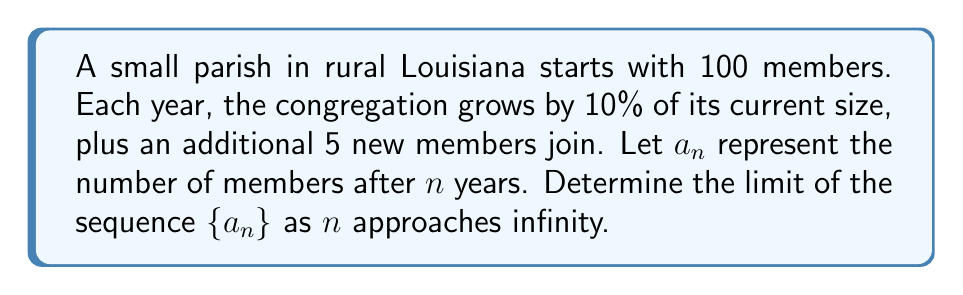Solve this math problem. Let's approach this step-by-step:

1) First, we need to find the recursive formula for $a_n$:
   $a_{n+1} = 1.1a_n + 5$, with $a_0 = 100$

2) To find the limit, we assume that the sequence converges to some value $L$. If it converges, then:
   $L = 1.1L + 5$

3) Solving this equation:
   $L - 1.1L = 5$
   $-0.1L = 5$
   $L = -50$

4) However, since we're dealing with a population, a negative limit doesn't make sense. This suggests that the sequence doesn't converge.

5) To prove divergence, let's look at the difference between consecutive terms:
   $a_{n+1} - a_n = (1.1a_n + 5) - a_n = 0.1a_n + 5$

6) This difference is always positive (since $a_n$ is always positive), meaning each term is larger than the previous one.

7) Moreover, as $n$ increases, $a_n$ increases, so $0.1a_n + 5$ also increases, meaning the difference between consecutive terms grows larger.

8) This implies that the sequence $\{a_n\}$ is strictly increasing and unbounded.

Therefore, the limit of the sequence as $n$ approaches infinity does not exist; the sequence diverges to positive infinity.
Answer: $\lim_{n \to \infty} a_n = \infty$ 